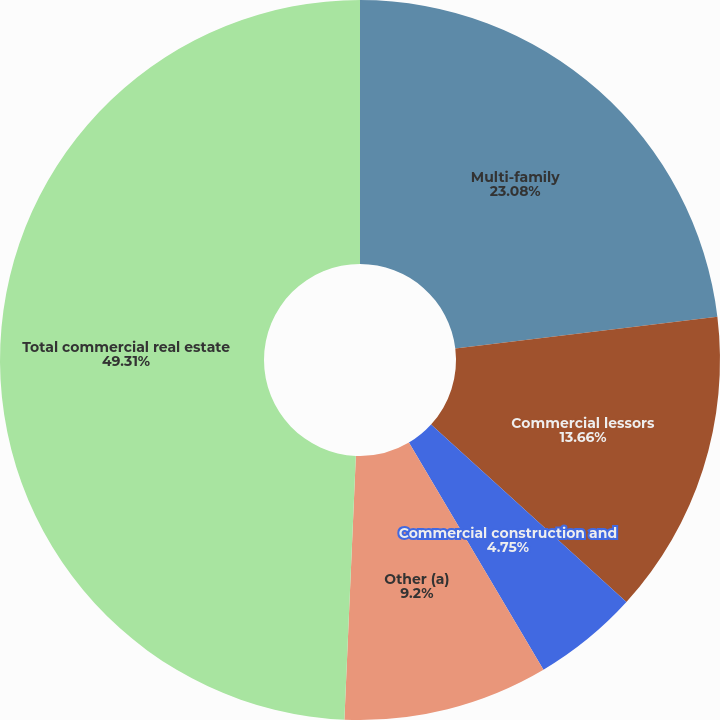Convert chart to OTSL. <chart><loc_0><loc_0><loc_500><loc_500><pie_chart><fcel>Multi-family<fcel>Commercial lessors<fcel>Commercial construction and<fcel>Other (a)<fcel>Total commercial real estate<nl><fcel>23.08%<fcel>13.66%<fcel>4.75%<fcel>9.2%<fcel>49.31%<nl></chart> 